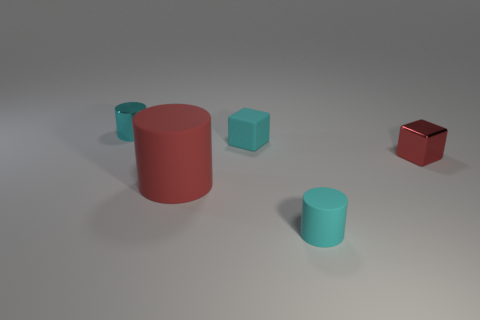Is there anything else that is the same size as the red cylinder?
Your answer should be compact. No. There is a tiny cube that is the same color as the big cylinder; what is its material?
Give a very brief answer. Metal. Does the small matte block have the same color as the thing that is behind the tiny cyan cube?
Provide a short and direct response. Yes. There is a rubber thing that is in front of the rubber block and to the right of the large matte cylinder; what is its size?
Your answer should be compact. Small. There is a metal thing to the left of the cyan thing that is in front of the tiny metal object in front of the tiny cyan metallic cylinder; how big is it?
Offer a terse response. Small. There is a cube right of the cyan block; is its size the same as the cyan object in front of the large rubber thing?
Offer a very short reply. Yes. There is a tiny cyan object that is made of the same material as the small red cube; what is its shape?
Give a very brief answer. Cylinder. There is a small cylinder in front of the metallic object behind the tiny metallic object that is right of the shiny cylinder; what color is it?
Ensure brevity in your answer.  Cyan. Are there fewer shiny blocks that are left of the small shiny cylinder than metal objects that are behind the small red thing?
Ensure brevity in your answer.  Yes. Is the cyan shiny thing the same shape as the big red rubber thing?
Provide a short and direct response. Yes. 